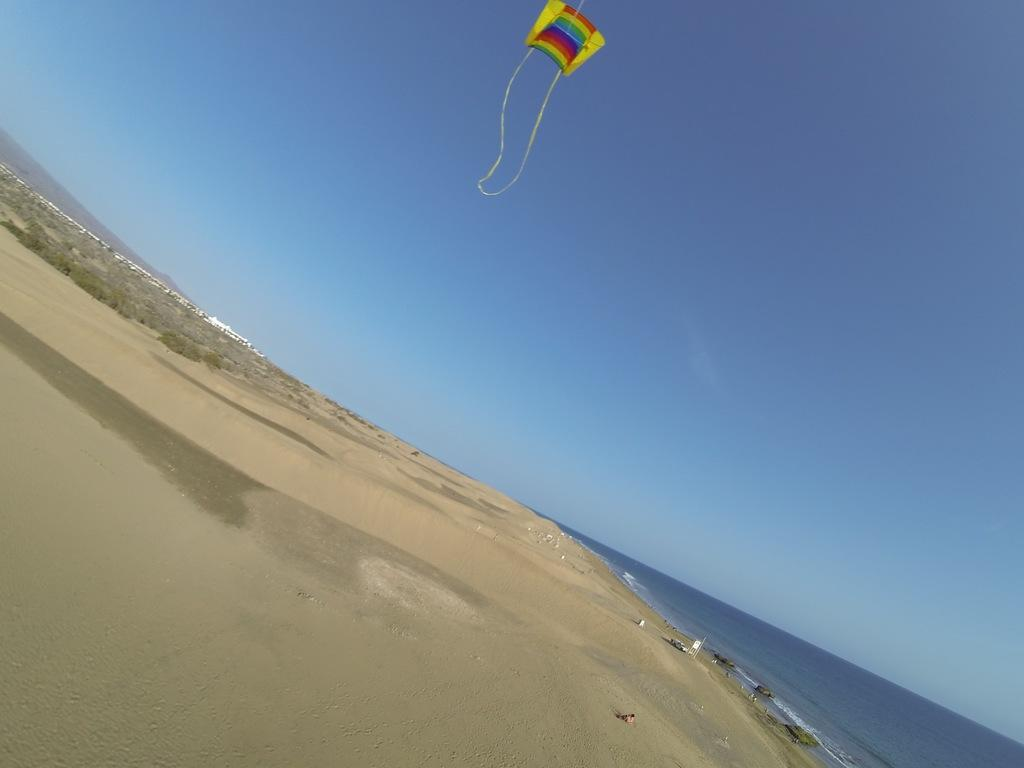Where was the image taken? The image was taken at a beach. What can be seen in the sky in the image? There is a kite in the sky in the image. What is visible at the bottom of the image? Water and sand are present at the bottom of the image. What type of skirt is being worn by the kite in the image? There is no skirt present in the image, as the kite is an object and not a person wearing clothing. 